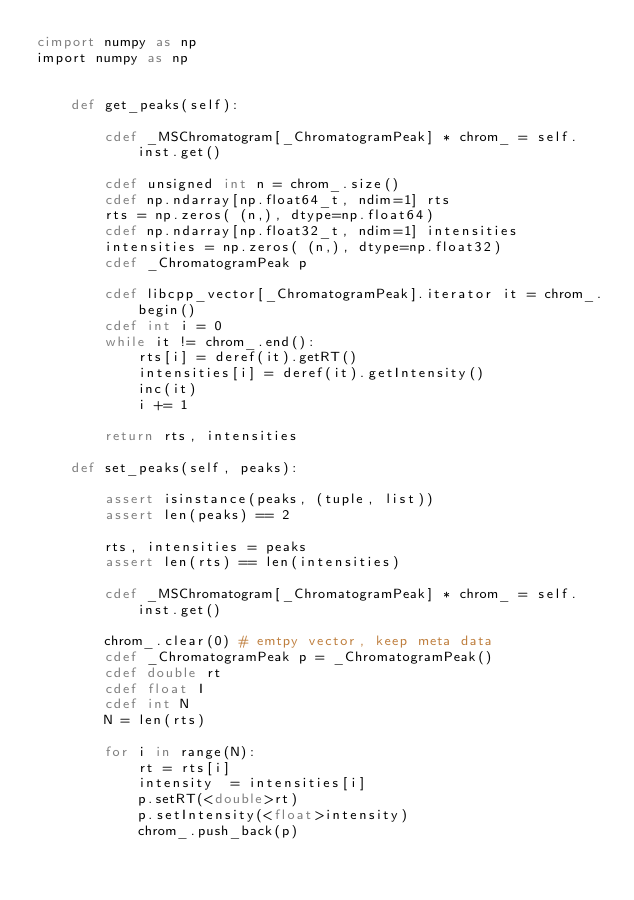<code> <loc_0><loc_0><loc_500><loc_500><_Cython_>cimport numpy as np
import numpy as np


    def get_peaks(self):

        cdef _MSChromatogram[_ChromatogramPeak] * chrom_ = self.inst.get()

        cdef unsigned int n = chrom_.size()
        cdef np.ndarray[np.float64_t, ndim=1] rts
        rts = np.zeros( (n,), dtype=np.float64)
        cdef np.ndarray[np.float32_t, ndim=1] intensities
        intensities = np.zeros( (n,), dtype=np.float32)
        cdef _ChromatogramPeak p

        cdef libcpp_vector[_ChromatogramPeak].iterator it = chrom_.begin()
        cdef int i = 0
        while it != chrom_.end():
            rts[i] = deref(it).getRT()
            intensities[i] = deref(it).getIntensity()
            inc(it)
            i += 1

        return rts, intensities

    def set_peaks(self, peaks):

        assert isinstance(peaks, (tuple, list))
        assert len(peaks) == 2

        rts, intensities = peaks
        assert len(rts) == len(intensities)

        cdef _MSChromatogram[_ChromatogramPeak] * chrom_ = self.inst.get()

        chrom_.clear(0) # emtpy vector, keep meta data
        cdef _ChromatogramPeak p = _ChromatogramPeak()
        cdef double rt
        cdef float I
        cdef int N
        N = len(rts)

        for i in range(N):
            rt = rts[i]
            intensity  = intensities[i]
            p.setRT(<double>rt)
            p.setIntensity(<float>intensity)
            chrom_.push_back(p)
</code> 